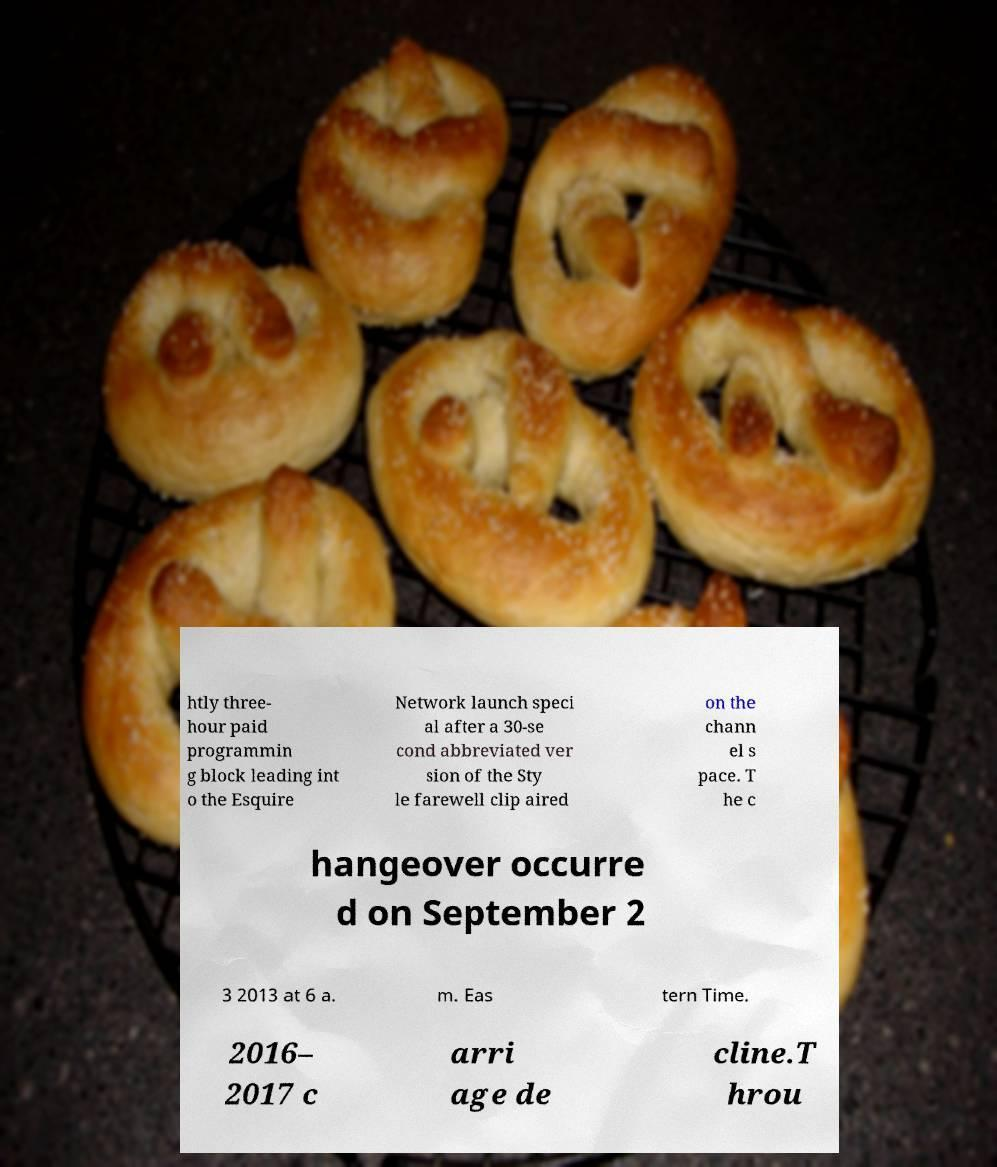Could you extract and type out the text from this image? htly three- hour paid programmin g block leading int o the Esquire Network launch speci al after a 30-se cond abbreviated ver sion of the Sty le farewell clip aired on the chann el s pace. T he c hangeover occurre d on September 2 3 2013 at 6 a. m. Eas tern Time. 2016– 2017 c arri age de cline.T hrou 